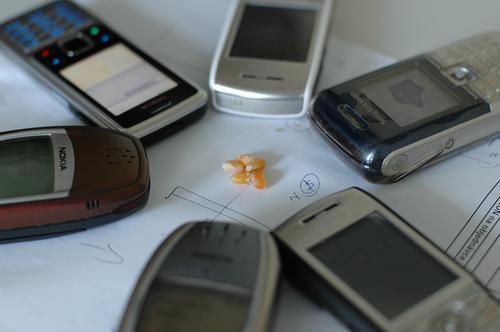How many cell phones are there?
Give a very brief answer. 6. 